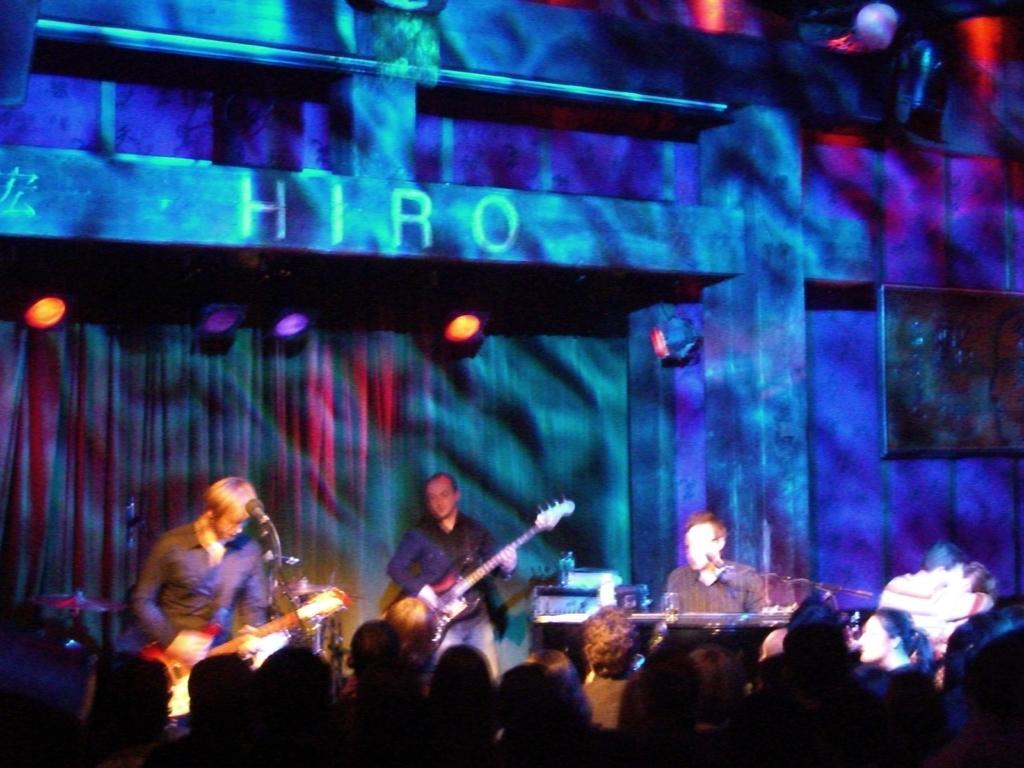Describe this image in one or two sentences. In this picture we can see three people playing musical instruments, the man on the side is playing a piano, the man on the middle playing a guitar and the man on the left side is playing a guitar in front of microphone. In front of the image there are group of people looking at them, in the background we can see lights here and a wall here. 